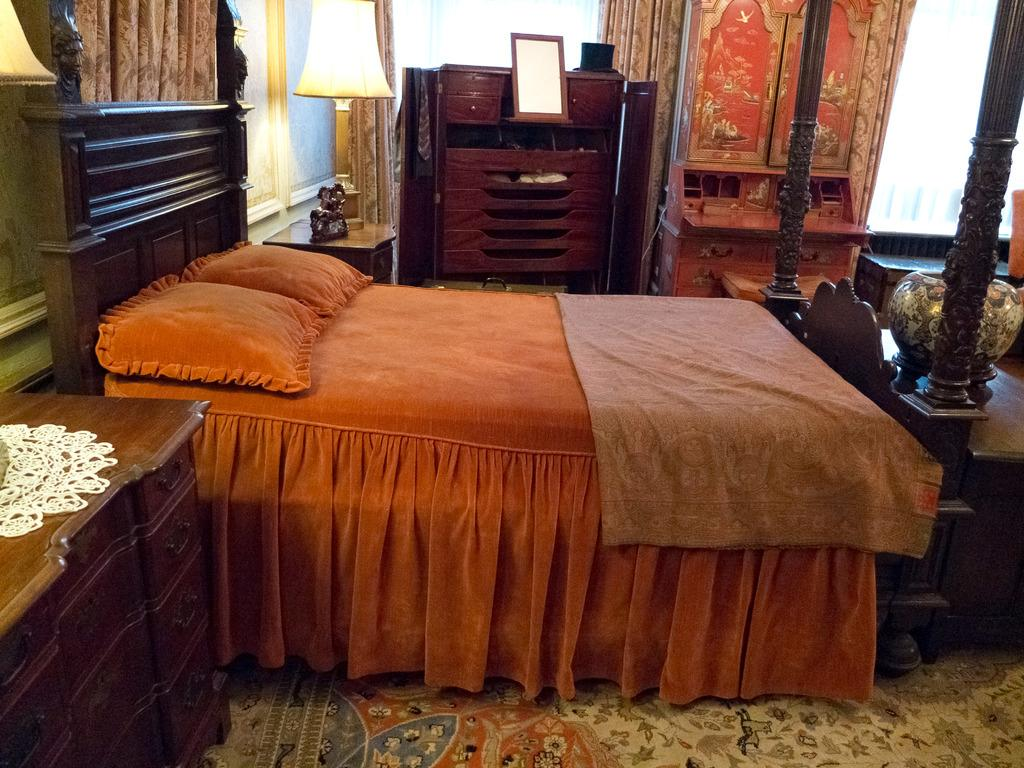What type of space is depicted in the image? The image shows an inside view of a room. What piece of furniture is present in the room? There is a bed in the room. What can be found on the bed? There are pillows on the bed. What is another object in the room that provides light? There is a lamp in the room. What type of storage furniture is in the room? There is a cupboard in the room. What rhythm is the maid using to clean the room in the image? There is no maid present in the image, and therefore no rhythm for cleaning can be observed. 